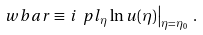<formula> <loc_0><loc_0><loc_500><loc_500>\ w b a r \equiv \left . i \ p l _ { \eta } \ln u ( \eta ) \right | _ { \eta = \eta _ { 0 } } \, .</formula> 